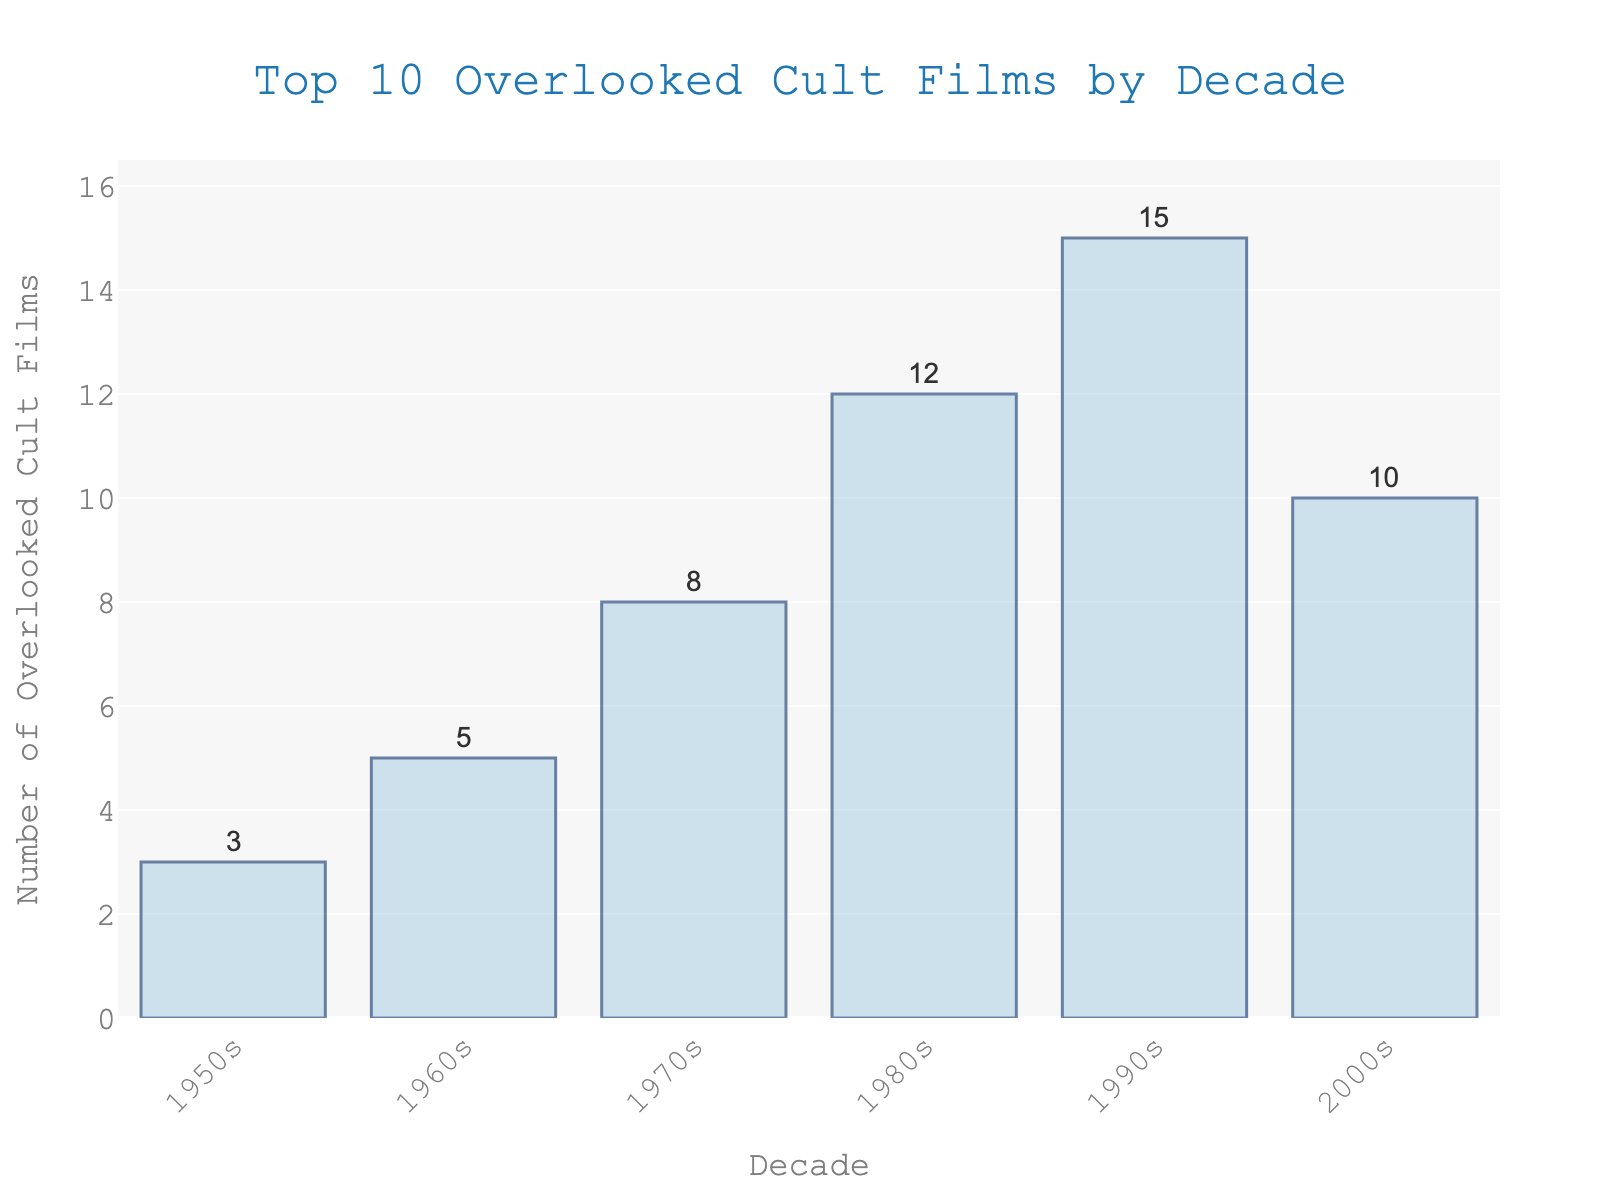What decade has the highest number of overlooked cult films? The tallest bar on the chart represents the 1990s with 15 overlooked cult films.
Answer: 1990s Which decade has fewer overlooked cult films, the 1980s or the 2000s? The bar for the 1980s has 12 films while the bar for the 2000s has 10 films, so the 2000s has fewer.
Answer: 2000s What's the total number of overlooked cult films from the 1950s to the 1970s combined? Sum the values for the 1950s (3), 1960s (5), and 1970s (8): 3 + 5 + 8 = 16.
Answer: 16 How many more overlooked cult films are in the 1990s compared to the 1950s? Subtract the number of films in the 1950s (3) from the number in the 1990s (15): 15 - 3 = 12.
Answer: 12 What's the average number of overlooked cult films per decade across all the decades listed? Sum all the values (3 + 5 + 8 + 12 + 15 + 10 = 53) and divide by the number of decades (6): 53 / 6 ≈ 8.83.
Answer: 8.83 How does the number of overlooked cult films in the 1960s compare to the 1980s? The 1960s have 5 films while the 1980s have 12 films. The 1980s have more.
Answer: 1980s What is the difference in the number of overlooked cult films between the decade with the most films and the decade with the fewest films? The most films is in the 1990s (15) and the fewest is in the 1950s (3). The difference is 15 - 3 = 12.
Answer: 12 What's the median number of overlooked cult films per decade? Arrange the values in order: 3, 5, 8, 10, 12, 15. With 6 values, the median is the average of the third and fourth values: (8 + 10) / 2 = 9.
Answer: 9 Which decade experienced the sharpest increase in the number of overlooked cult films compared to the previous decade? Calculating the differences between consecutive decades: 1950s to 1960s (5 - 3 = 2), 1960s to 1970s (8 - 5 = 3), 1970s to 1980s (12 - 8 = 4), 1980s to 1990s (15 - 12 = 3), 1990s to 2000s (10 - 15 = -5). The sharpest increase is from the 1970s to 1980s with an increase of 4 films.
Answer: 1970s to 1980s 